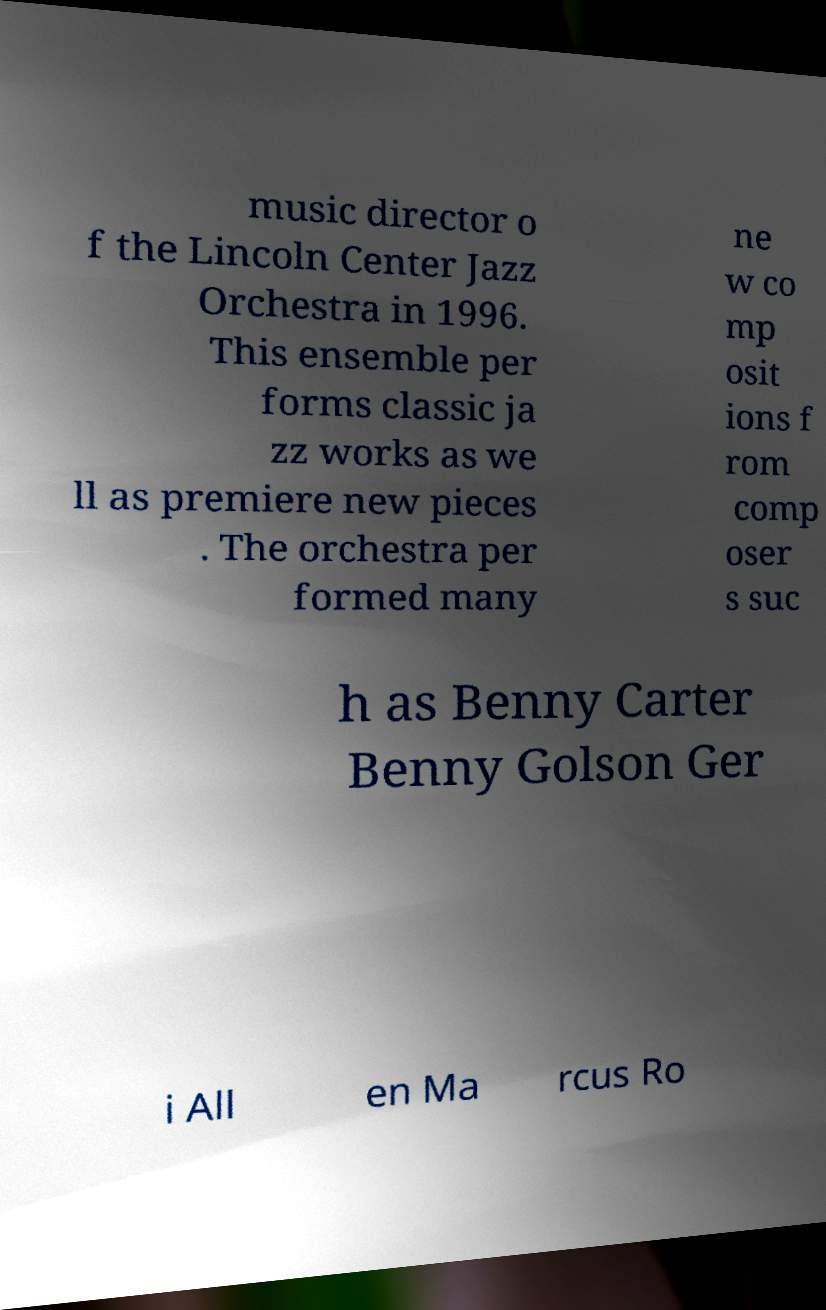Please identify and transcribe the text found in this image. music director o f the Lincoln Center Jazz Orchestra in 1996. This ensemble per forms classic ja zz works as we ll as premiere new pieces . The orchestra per formed many ne w co mp osit ions f rom comp oser s suc h as Benny Carter Benny Golson Ger i All en Ma rcus Ro 